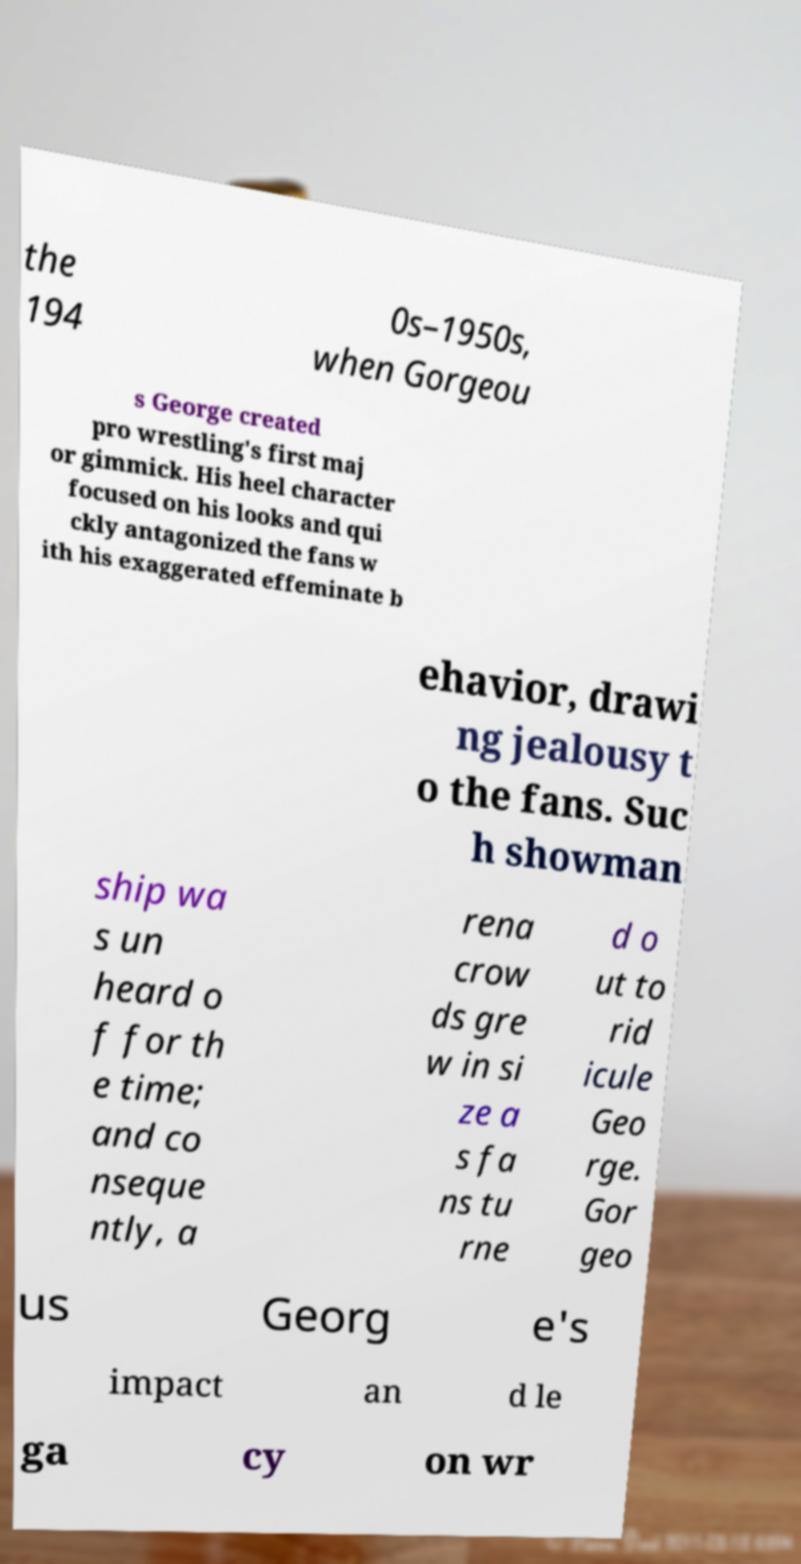I need the written content from this picture converted into text. Can you do that? the 194 0s–1950s, when Gorgeou s George created pro wrestling's first maj or gimmick. His heel character focused on his looks and qui ckly antagonized the fans w ith his exaggerated effeminate b ehavior, drawi ng jealousy t o the fans. Suc h showman ship wa s un heard o f for th e time; and co nseque ntly, a rena crow ds gre w in si ze a s fa ns tu rne d o ut to rid icule Geo rge. Gor geo us Georg e's impact an d le ga cy on wr 